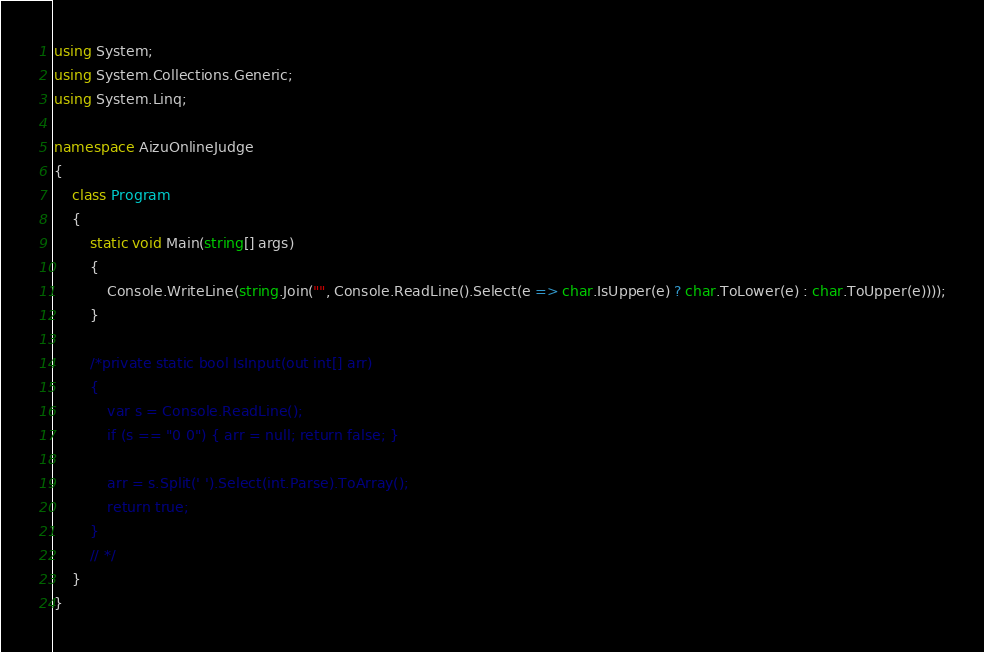Convert code to text. <code><loc_0><loc_0><loc_500><loc_500><_C#_>using System;
using System.Collections.Generic;
using System.Linq;

namespace AizuOnlineJudge
{
    class Program
    {
        static void Main(string[] args)
        {
            Console.WriteLine(string.Join("", Console.ReadLine().Select(e => char.IsUpper(e) ? char.ToLower(e) : char.ToUpper(e))));
        }

        /*private static bool IsInput(out int[] arr)
        {
            var s = Console.ReadLine();
            if (s == "0 0") { arr = null; return false; }

            arr = s.Split(' ').Select(int.Parse).ToArray();
            return true;
        }
        // */
    }
}
</code> 